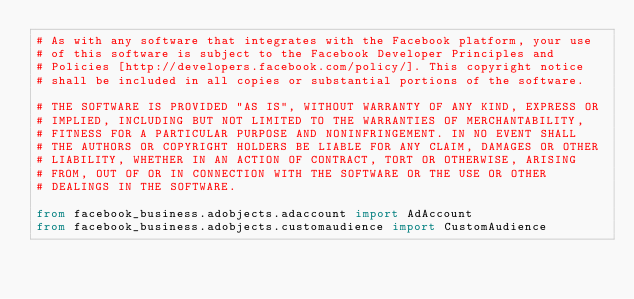Convert code to text. <code><loc_0><loc_0><loc_500><loc_500><_Python_># As with any software that integrates with the Facebook platform, your use
# of this software is subject to the Facebook Developer Principles and
# Policies [http://developers.facebook.com/policy/]. This copyright notice
# shall be included in all copies or substantial portions of the software.

# THE SOFTWARE IS PROVIDED "AS IS", WITHOUT WARRANTY OF ANY KIND, EXPRESS OR
# IMPLIED, INCLUDING BUT NOT LIMITED TO THE WARRANTIES OF MERCHANTABILITY,
# FITNESS FOR A PARTICULAR PURPOSE AND NONINFRINGEMENT. IN NO EVENT SHALL
# THE AUTHORS OR COPYRIGHT HOLDERS BE LIABLE FOR ANY CLAIM, DAMAGES OR OTHER
# LIABILITY, WHETHER IN AN ACTION OF CONTRACT, TORT OR OTHERWISE, ARISING
# FROM, OUT OF OR IN CONNECTION WITH THE SOFTWARE OR THE USE OR OTHER
# DEALINGS IN THE SOFTWARE.

from facebook_business.adobjects.adaccount import AdAccount
from facebook_business.adobjects.customaudience import CustomAudience</code> 